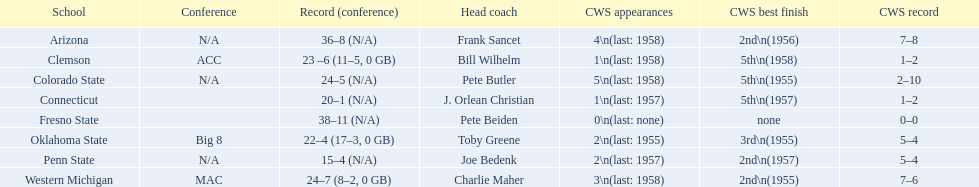List each of the schools that came in 2nd for cws best finish. Arizona, Penn State, Western Michigan. 